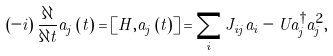Convert formula to latex. <formula><loc_0><loc_0><loc_500><loc_500>\left ( - i \right ) \frac { \partial } { \partial t } a _ { j } \left ( t \right ) = \left [ H , a _ { j } \left ( t \right ) \right ] = \sum _ { i } J _ { i j } a _ { i } - U a _ { j } ^ { \dagger } a _ { j } ^ { 2 } ,</formula> 